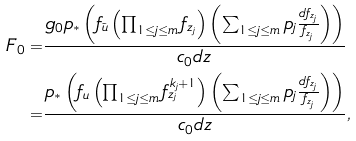Convert formula to latex. <formula><loc_0><loc_0><loc_500><loc_500>F _ { 0 } = & \frac { g _ { 0 } p _ { * } \left ( f _ { \tilde { u } } \left ( \prod _ { 1 \leq j \leq m } f _ { z _ { j } } \right ) \left ( \sum _ { 1 \leq j \leq m } p _ { j } \frac { d f _ { z _ { j } } } { f _ { z _ { j } } } \right ) \right ) } { c _ { 0 } d z } \\ = & \frac { p _ { * } \left ( f _ { u } \left ( \prod _ { 1 \leq j \leq m } f ^ { k _ { j } + 1 } _ { z _ { j } } \right ) \left ( \sum _ { 1 \leq j \leq m } p _ { j } \frac { d f _ { z _ { j } } } { f _ { z _ { j } } } \right ) \right ) } { c _ { 0 } d z } ,</formula> 